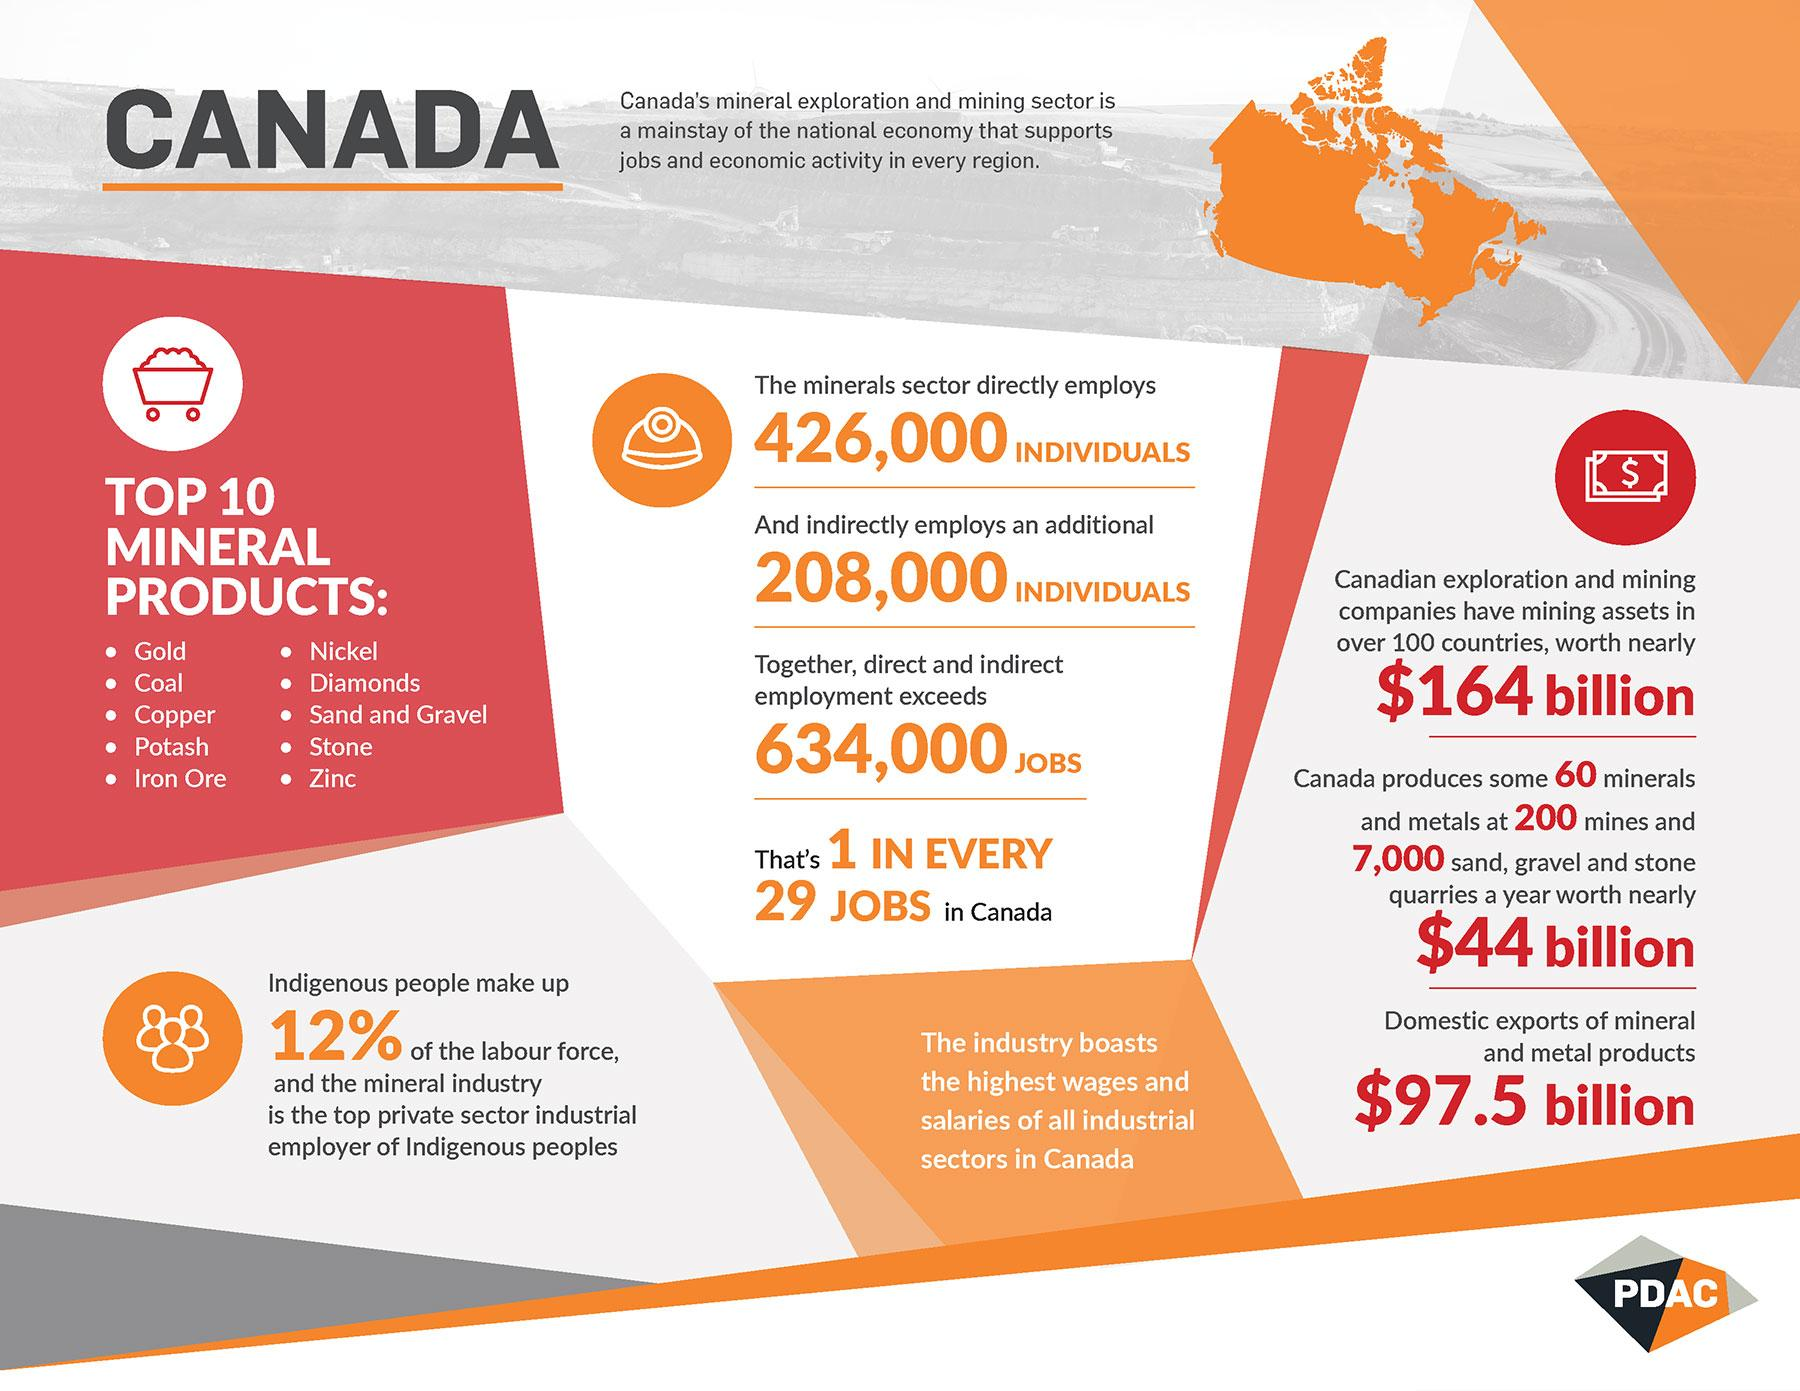Give some essential details in this illustration. In the mineral sector, there are approximately 208,000 jobs that are indirectly supported by the industry. In total, approximately 634,000 individuals are employed directly and indirectly by the mineral sector. Out of the top 10 minerals that start with the alphabet C, coal and copper are two of the most prominent examples. The mineral industry is known for having the highest wages and salaries among all industries. The currency logo displays the sign, indicating the currency's denomination, such as $100 for a hundred-dollar bill. 